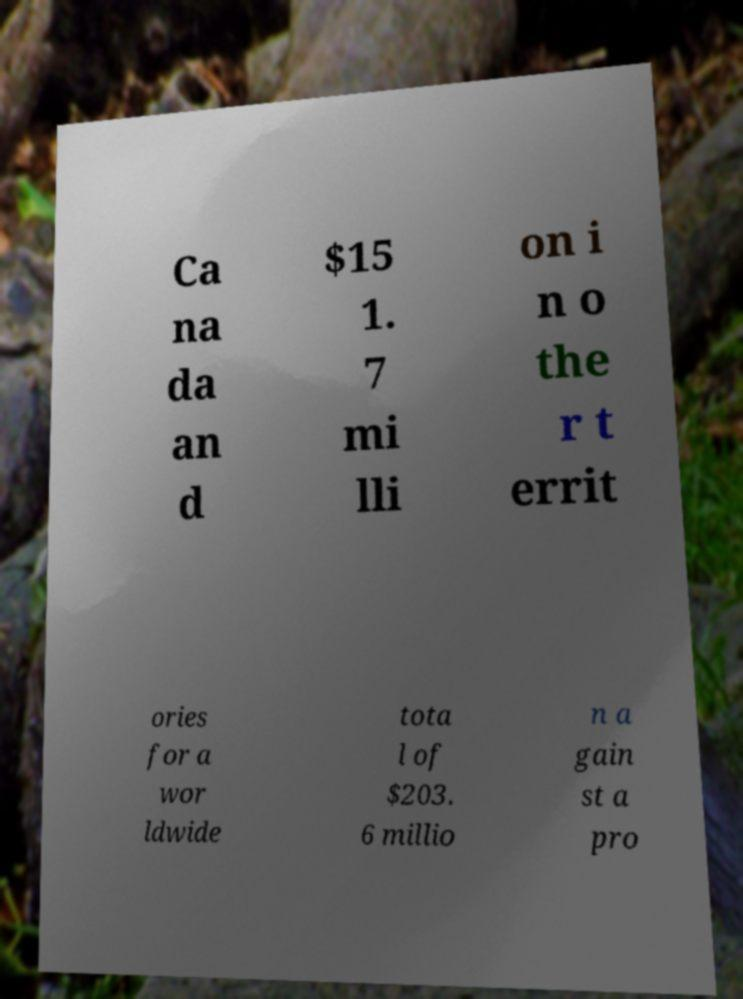Could you extract and type out the text from this image? Ca na da an d $15 1. 7 mi lli on i n o the r t errit ories for a wor ldwide tota l of $203. 6 millio n a gain st a pro 